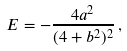<formula> <loc_0><loc_0><loc_500><loc_500>E = - \frac { 4 a ^ { 2 } } { ( 4 + b ^ { 2 } ) ^ { 2 } } \, ,</formula> 